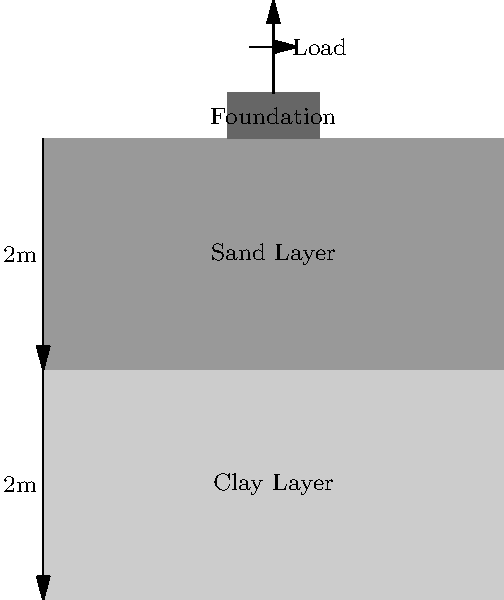As a computer science student exploring cloud-based structural analysis tools, you're tasked with calculating the total settlement of a building foundation. The foundation rests on a layered soil profile consisting of a 2m thick clay layer ($$E_1 = 20 \text{ MPa}$$, $$\nu_1 = 0.3$$) overlying a 2m thick sand layer ($$E_2 = 50 \text{ MPa}$$, $$\nu_2 = 0.25$$). The foundation applies a uniform pressure of 200 kPa over a 2m x 2m area. Using the elastic settlement equation $$S = q B \frac{(1-\nu^2)}{E} I_s$$, where $$I_s = 0.95$$ for this case, calculate the total settlement of the foundation. Assume the influence depth is 4m (i.e., consider both soil layers). To solve this problem, we'll follow these steps:

1) We'll use the elastic settlement equation for each layer:
   $$S = q B \frac{(1-\nu^2)}{E} I_s$$

2) Given:
   - q = 200 kPa (applied pressure)
   - B = 2m (foundation width)
   - $$I_s$$ = 0.95 (influence factor)

3) For the clay layer (1):
   $$S_1 = 200 \cdot 2 \cdot \frac{(1-0.3^2)}{20 \cdot 10^6} \cdot 0.95 = 1.71 \cdot 10^{-5} \text{ m}$$

4) For the sand layer (2):
   $$S_2 = 200 \cdot 2 \cdot \frac{(1-0.25^2)}{50 \cdot 10^6} \cdot 0.95 = 0.68 \cdot 10^{-5} \text{ m}$$

5) Total settlement is the sum of both layers:
   $$S_{\text{total}} = S_1 + S_2 = (1.71 + 0.68) \cdot 10^{-5} = 2.39 \cdot 10^{-5} \text{ m}$$

6) Convert to mm:
   $$S_{\text{total}} = 2.39 \cdot 10^{-5} \cdot 1000 = 0.239 \text{ mm}$$
Answer: 0.239 mm 